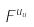Convert formula to latex. <formula><loc_0><loc_0><loc_500><loc_500>F ^ { u _ { u } }</formula> 